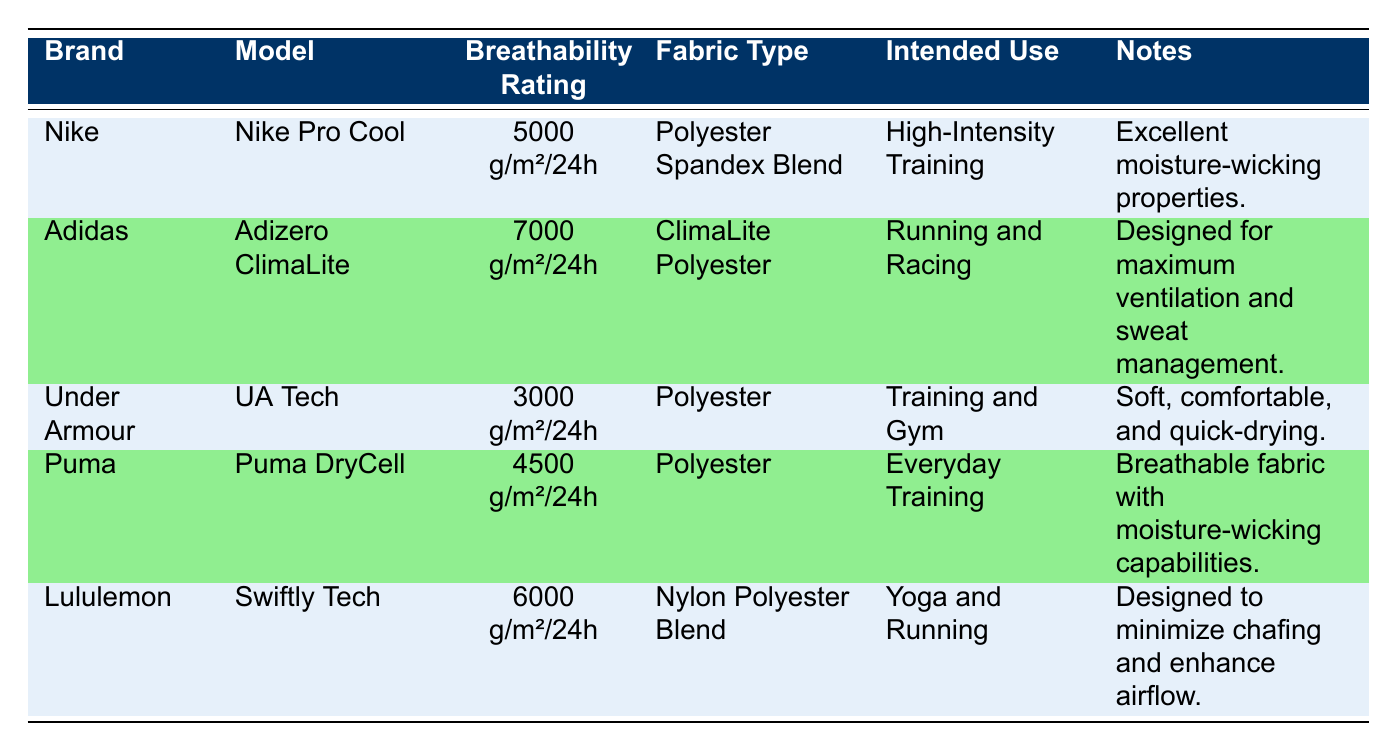What is the breathability rating of Adidas Adizero ClimaLite? The table specifies that the Adidas Adizero ClimaLite has a breathability rating of "7000 g/m²/24h."
Answer: 7000 g/m²/24h Which brand has the lowest breathability rating? By examining the breathability ratings listed, Under Armour's UA Tech has the lowest at "3000 g/m²/24h."
Answer: Under Armour How many brands have a breathability rating of 5000 g/m²/24h or above? The brands with ratings of 5000 g/m²/24h or above are Nike, Adidas, Lululemon, and Puma. This totals to four brands.
Answer: 4 Is the fabric used in Lululemon Swiftly Tech a Polyester Spandex Blend? The table shows that Lululemon Swiftly Tech uses a Nylon Polyester Blend, therefore the statement is false.
Answer: No What is the average breathability rating of all the clothing items listed? First, we convert the ratings to numerical values: 5000, 7000, 3000, 4500, and 6000. Summing these gives 23000. Then, divide by 5 (the number of brands): 23000 / 5 = 4600.
Answer: 4600 g/m²/24h Which model is intended for High-Intensity Training? From the table, the Nike Pro Cool model is specifically stated to be for High-Intensity Training.
Answer: Nike Pro Cool Does any clothing item have a breathability rating of 4000 g/m²/24h? The table shows ratings of 3000, 4500, 5000, 6000, and 7000 g/m²/24h but does not list 4000 g/m²/24h. Thus, the answer is no.
Answer: No Which brands are designed for running and racing? The table indicates that the Adidas Adizero ClimaLite is intended for running and racing. Comparing this with others, Adidas is the sole brand listed for this use case.
Answer: Adidas 